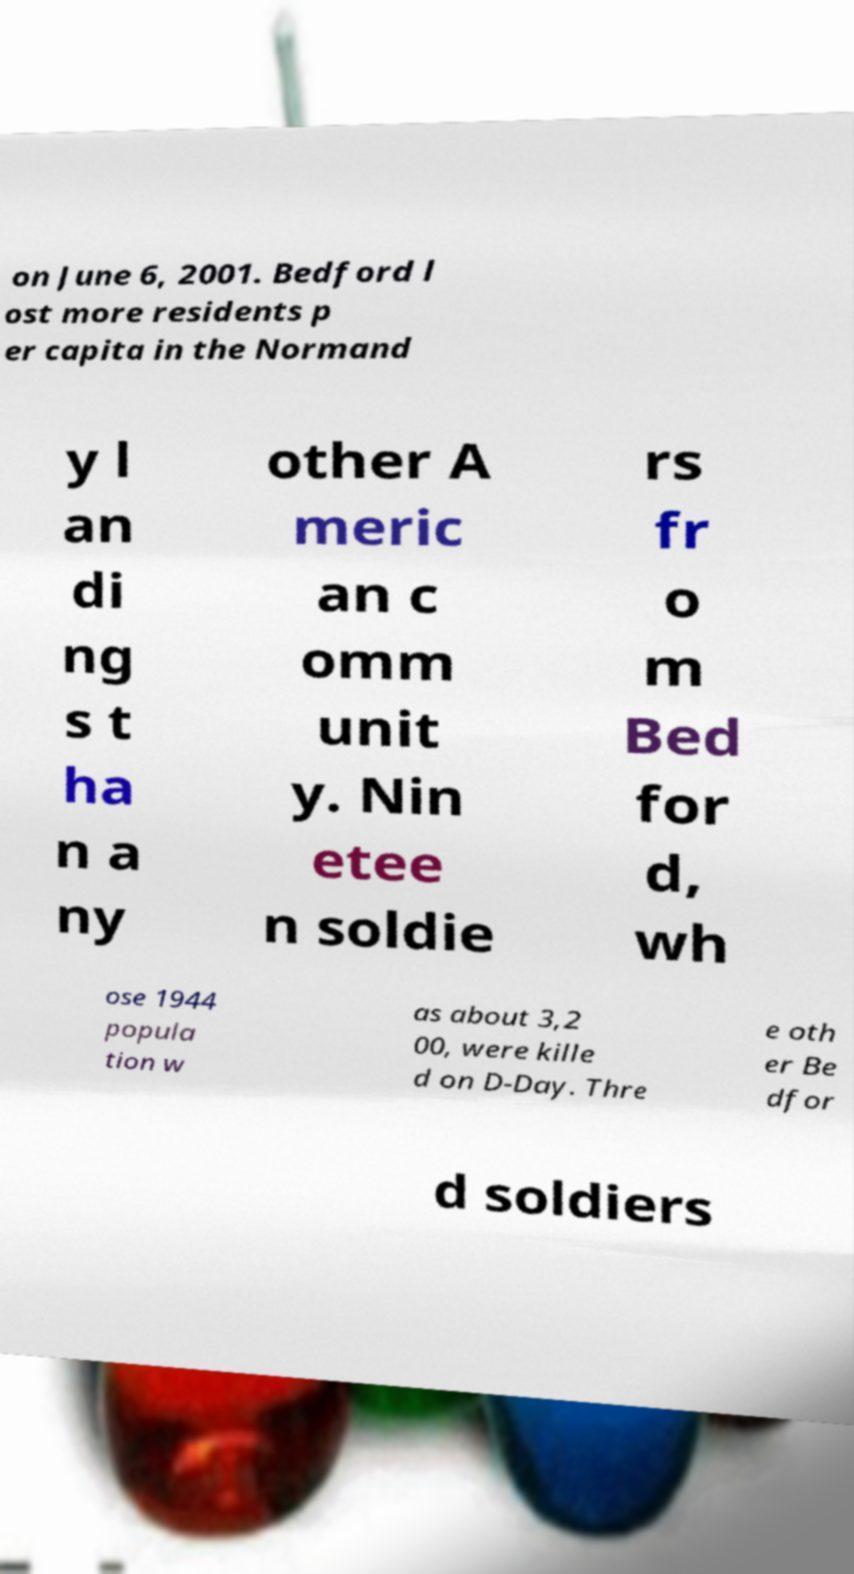For documentation purposes, I need the text within this image transcribed. Could you provide that? on June 6, 2001. Bedford l ost more residents p er capita in the Normand y l an di ng s t ha n a ny other A meric an c omm unit y. Nin etee n soldie rs fr o m Bed for d, wh ose 1944 popula tion w as about 3,2 00, were kille d on D-Day. Thre e oth er Be dfor d soldiers 